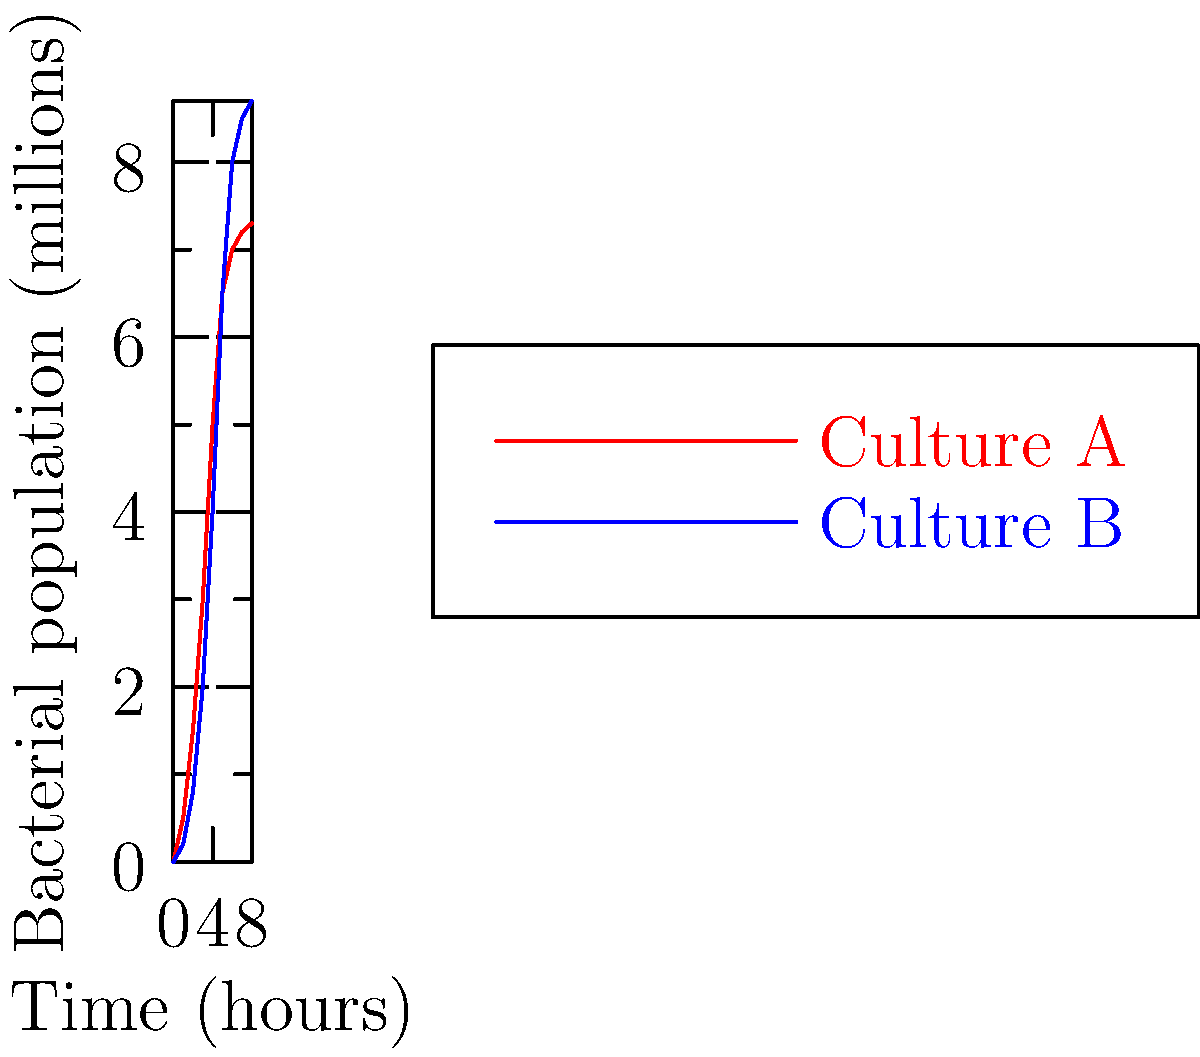The graph shows the growth curves of two bacterial cultures, A and B, over 8 hours. Based on your expertise in early disease detection using AI, which culture would you recommend for developing a rapid bacterial growth detection system, and why? To answer this question, we need to analyze the growth patterns of both cultures:

1. Examine the lag phase:
   Culture A: Shorter lag phase (0-1 hours)
   Culture B: Longer lag phase (0-2 hours)

2. Compare exponential growth rates:
   Culture A: Steeper slope from 1-5 hours
   Culture B: Less steep slope from 2-6 hours

3. Analyze the stationary phase:
   Culture A: Reaches stationary phase earlier (around 6 hours)
   Culture B: Reaches stationary phase later (around 7-8 hours)

4. Consider final population size:
   Culture A: Lower final population (about 7.3 million)
   Culture B: Higher final population (about 8.7 million)

For a rapid bacterial growth detection system, Culture A would be more suitable because:

1. It has a shorter lag phase, allowing for quicker initiation of growth.
2. It exhibits a faster exponential growth rate, which would be easier to detect and measure in a shorter time frame.
3. It reaches the stationary phase earlier, providing a complete growth curve in less time.

These characteristics would enable faster and more efficient early detection of bacterial growth, which is crucial for timely disease diagnosis and intervention.
Answer: Culture A, due to shorter lag phase and faster exponential growth. 